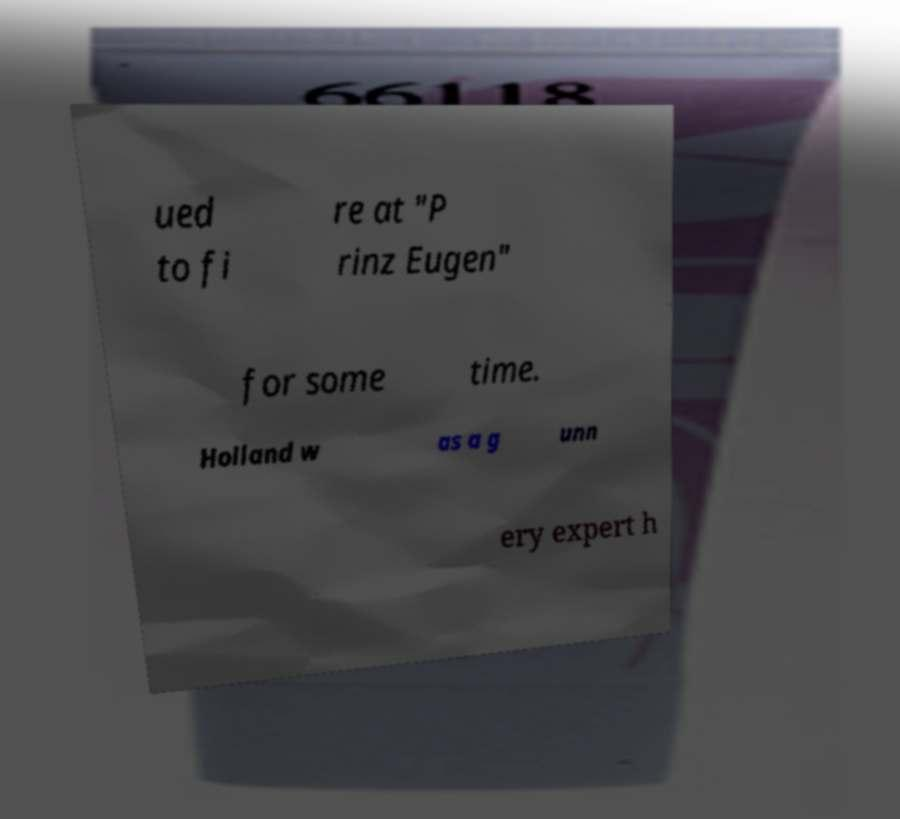Can you read and provide the text displayed in the image?This photo seems to have some interesting text. Can you extract and type it out for me? ued to fi re at "P rinz Eugen" for some time. Holland w as a g unn ery expert h 